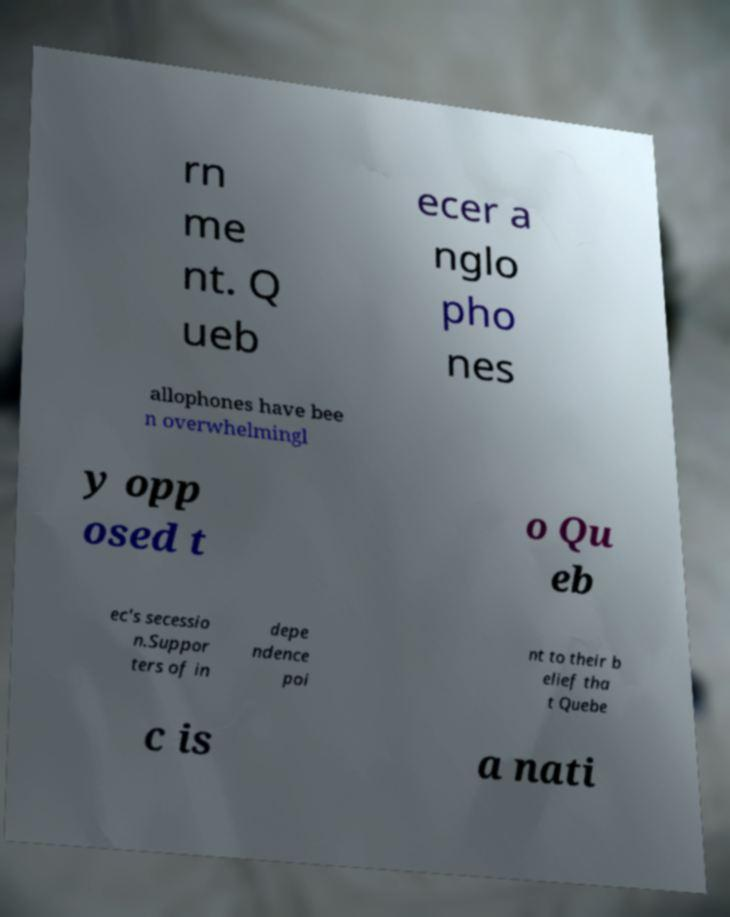For documentation purposes, I need the text within this image transcribed. Could you provide that? rn me nt. Q ueb ecer a nglo pho nes allophones have bee n overwhelmingl y opp osed t o Qu eb ec's secessio n.Suppor ters of in depe ndence poi nt to their b elief tha t Quebe c is a nati 